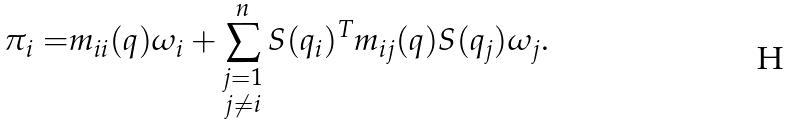Convert formula to latex. <formula><loc_0><loc_0><loc_500><loc_500>\pi _ { i } = & m _ { i i } ( q ) \omega _ { i } + \sum _ { \substack { j = 1 \\ j \neq i } } ^ { n } S ( q _ { i } ) ^ { T } m _ { i j } ( q ) S ( q _ { j } ) \omega _ { j } .</formula> 